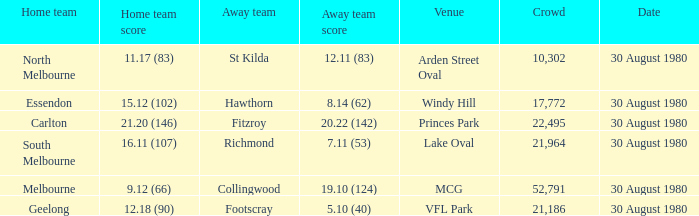What was the assembly when the guest team is footscray? 21186.0. 